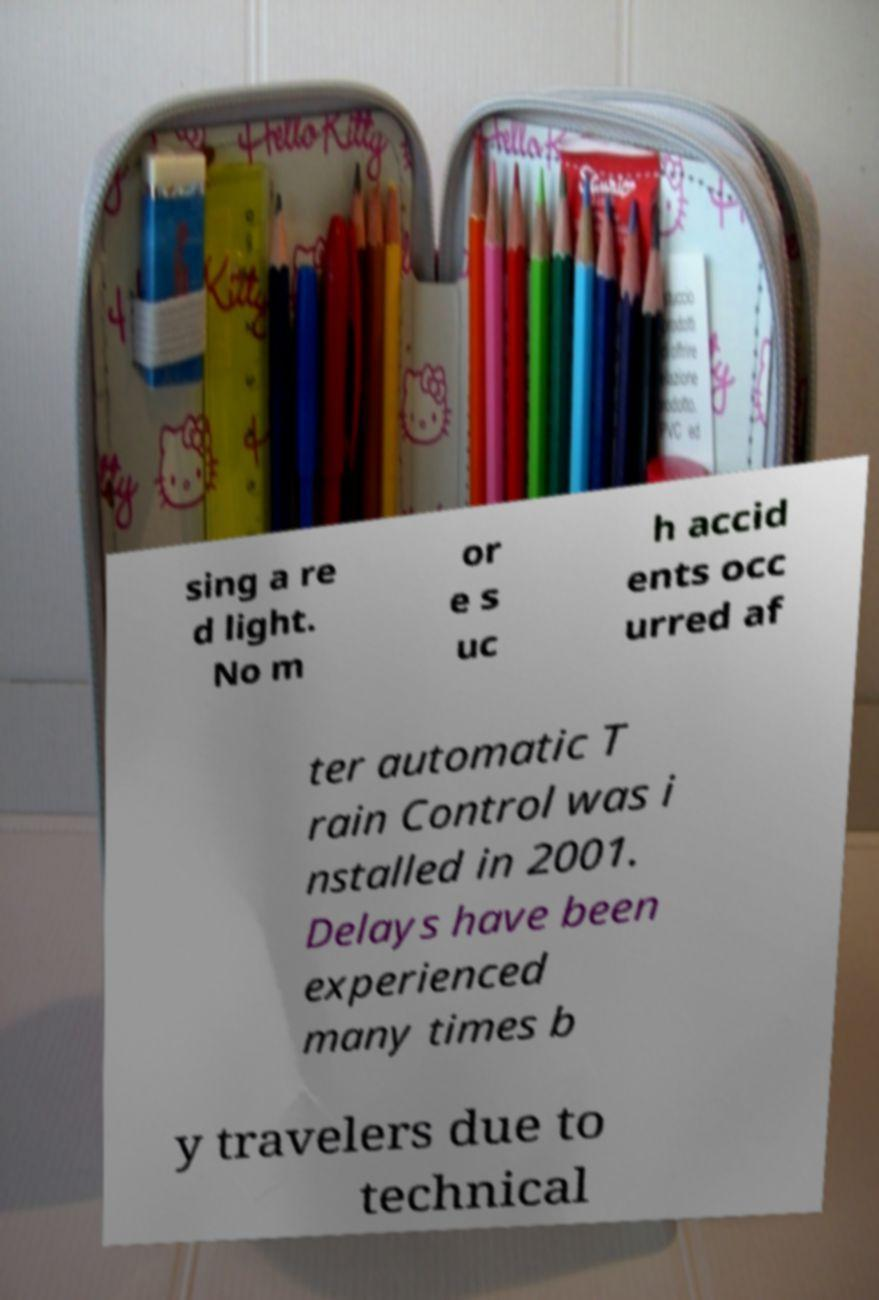Can you read and provide the text displayed in the image?This photo seems to have some interesting text. Can you extract and type it out for me? sing a re d light. No m or e s uc h accid ents occ urred af ter automatic T rain Control was i nstalled in 2001. Delays have been experienced many times b y travelers due to technical 